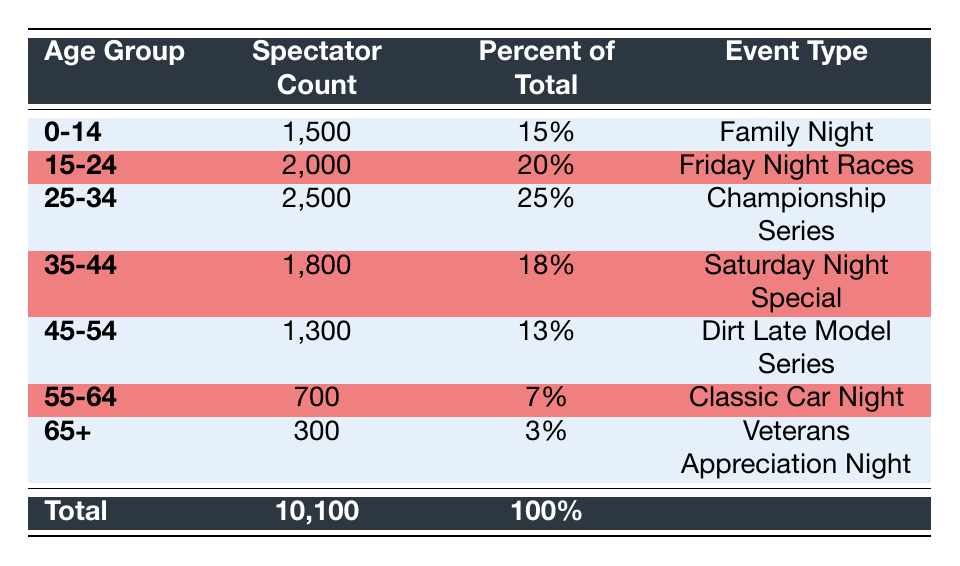What age group has the highest spectator count? By examining the spectator count column, the age group "25-34" shows the highest count with 2500 spectators.
Answer: 25-34 What percentage of the total spectators are aged 55-64? The age group "55-64" has 700 spectators, and the total spectators is 10100. To find the percentage, (700/10100) * 100 = 6.93%, which rounds to approximately 7%.
Answer: 7% Is the number of spectators aged 0-14 greater than those aged 65+? The spectator count for age group "0-14" is 1500, and for "65+" it is 300. Since 1500 is greater than 300, the statement is true.
Answer: Yes What is the total spectator count for the age groups 35-54? To find the total, we add the spectator counts of the age groups "35-44" (1800) and "45-54" (1300). Thus, 1800 + 1300 = 3100.
Answer: 3100 What age group represents the smallest percentage of total spectators? The smallest percentage of total spectators is found in the "65+" age group with 3%. This is the lowest value in the percent of total column.
Answer: 65+ What is the average spectator count across all age groups? We sum the spectator counts: 1500 + 2000 + 2500 + 1800 + 1300 + 700 + 300 = 10100. There are 7 age groups, so the average is 10100/7 ≈ 1442.86, which we can round to 1443.
Answer: 1443 Is the event type "Championship Series" attended mostly by spectators aged 25-34? The "Championship Series" has 2500 spectators all from the age group "25-34". Therefore, it can be concluded that this age group primarily attends this event type.
Answer: Yes Which age group constitutes more than a fifth of the total spectators? The age group "25-34" has 2500 spectators, representing 25% of the total (2500/10100 * 100). Since 25% is greater than 20%, this age group qualifies.
Answer: 25-34 